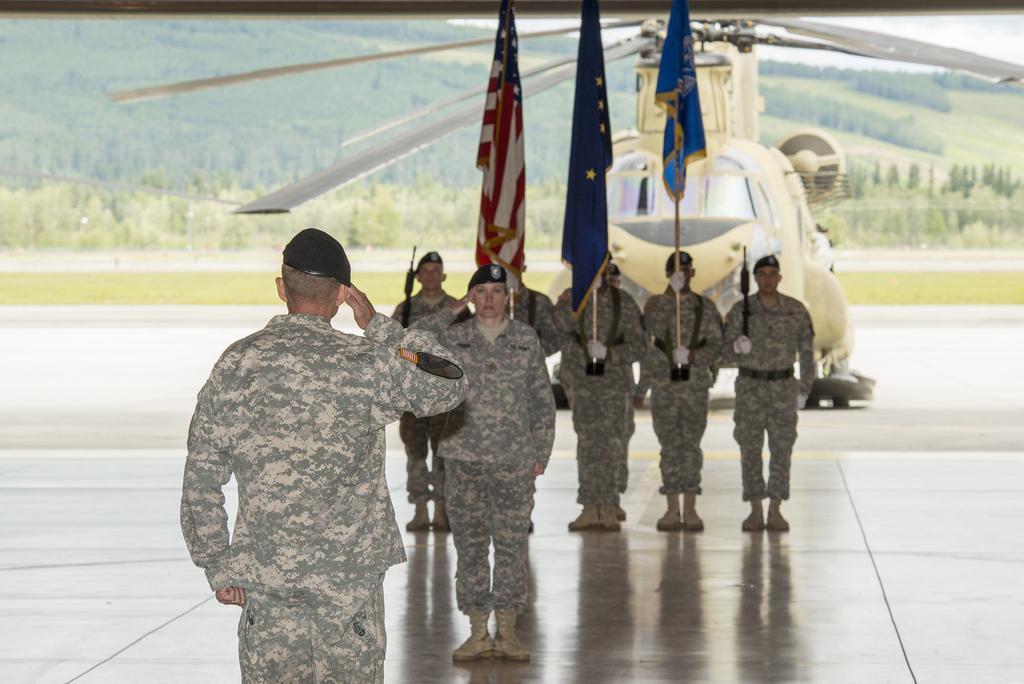Can you describe this image briefly? In this picture I can see there are few people standing and there are three people standing and holding the flags and in the backdrop I can see there is a helicopter and there are trees, mountains and the sky is clear. 